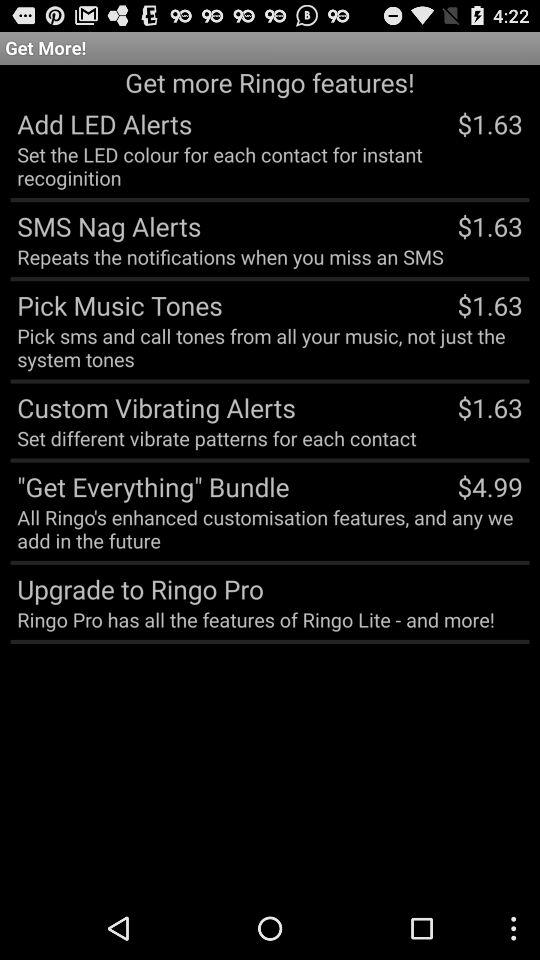What is the price of custom vibrating alerts? The price of custom vibrating alerts is $1.63. 